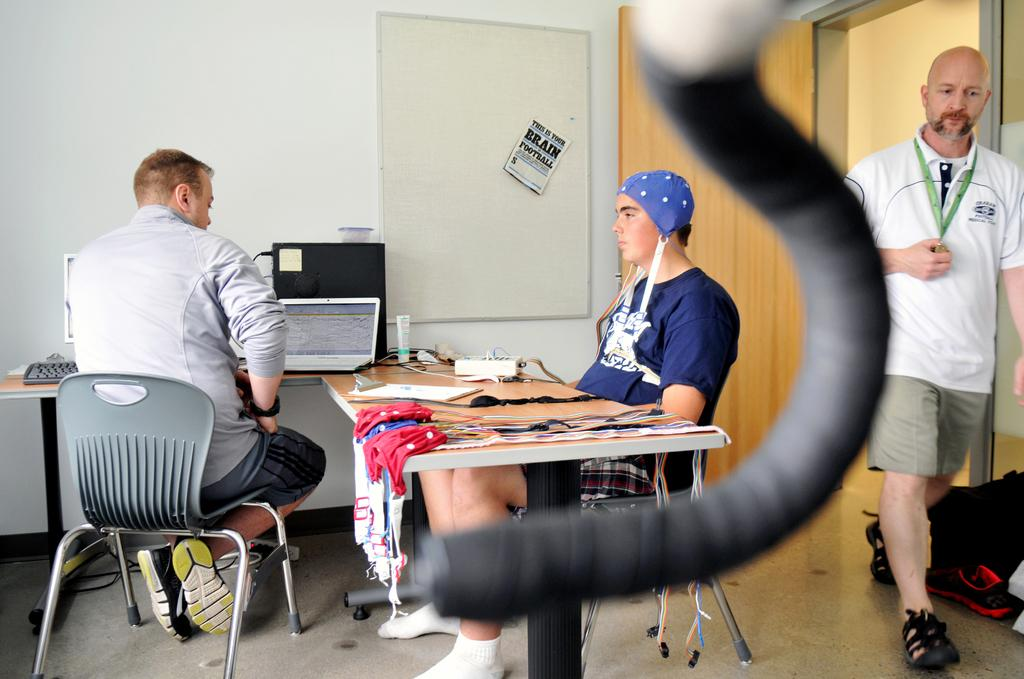How many men are in the image? There are three men in the image. What are the positions of the men in the image? One man is standing, while two are seated on chairs. What can be seen in the background of the image? There is a wall, a door, and a laptop in the background of the image. What else is present in the background of the image? There are a few things on a table in the background of the image. What type of wine is being served in the image? There is no wine present in the image. Is there a tent visible in the image? No, there is no tent visible in the image. 